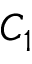<formula> <loc_0><loc_0><loc_500><loc_500>C _ { 1 }</formula> 